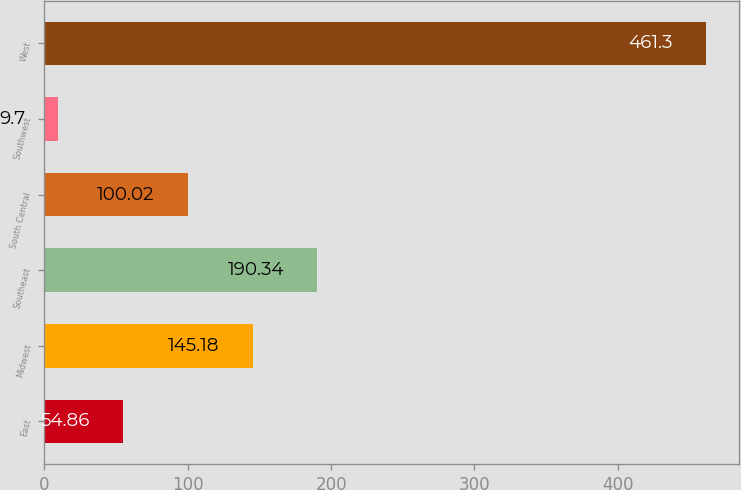Convert chart. <chart><loc_0><loc_0><loc_500><loc_500><bar_chart><fcel>East<fcel>Midwest<fcel>Southeast<fcel>South Central<fcel>Southwest<fcel>West<nl><fcel>54.86<fcel>145.18<fcel>190.34<fcel>100.02<fcel>9.7<fcel>461.3<nl></chart> 